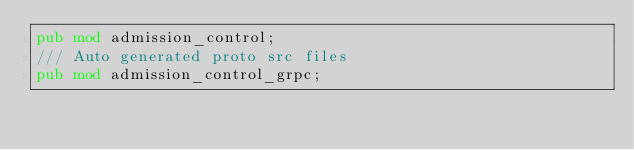<code> <loc_0><loc_0><loc_500><loc_500><_Rust_>pub mod admission_control;
/// Auto generated proto src files
pub mod admission_control_grpc;
</code> 